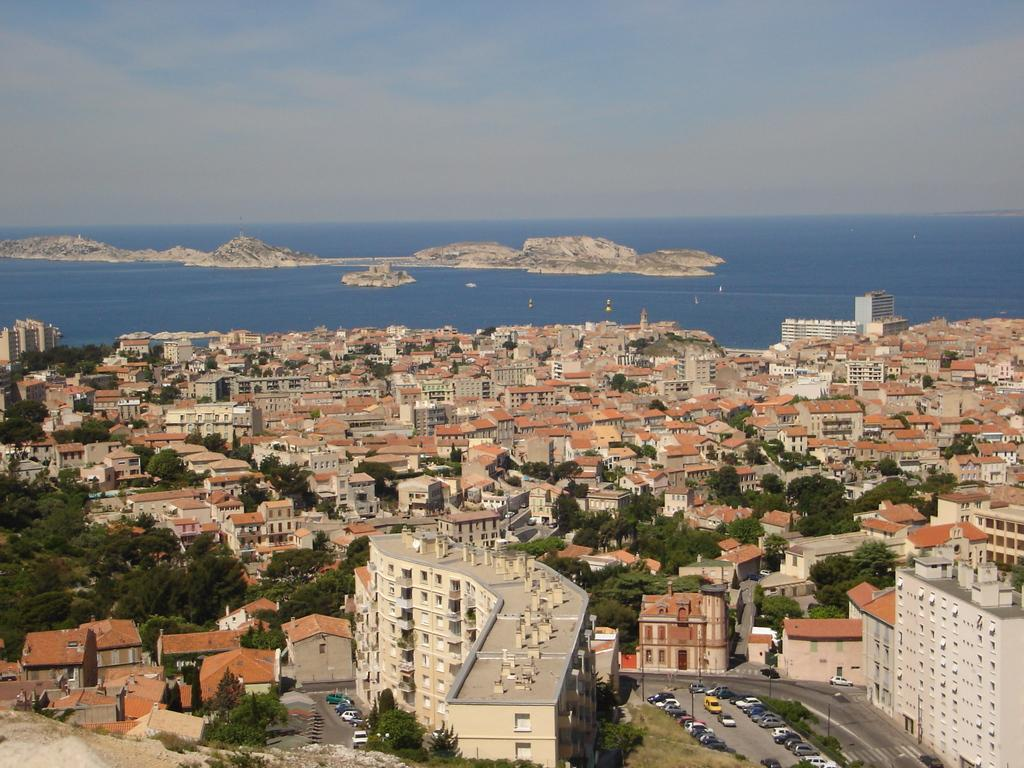What type of structures can be seen in the image? There are buildings in the image. What else is present in the image besides buildings? There are vehicles and trees visible in the image. What is visible at the top of the image? The sky is visible at the top of the image. Can you tell me how many donkeys are grazing under the trees in the image? There are no donkeys present in the image; it features buildings, vehicles, trees, and a visible sky. What taste does the sky have in the image? The sky does not have a taste, as it is a natural atmospheric phenomenon and not a consumable item. 